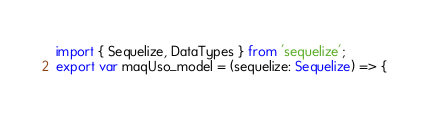Convert code to text. <code><loc_0><loc_0><loc_500><loc_500><_TypeScript_>import { Sequelize, DataTypes } from 'sequelize';
export var maqUso_model = (sequelize: Sequelize) => {</code> 